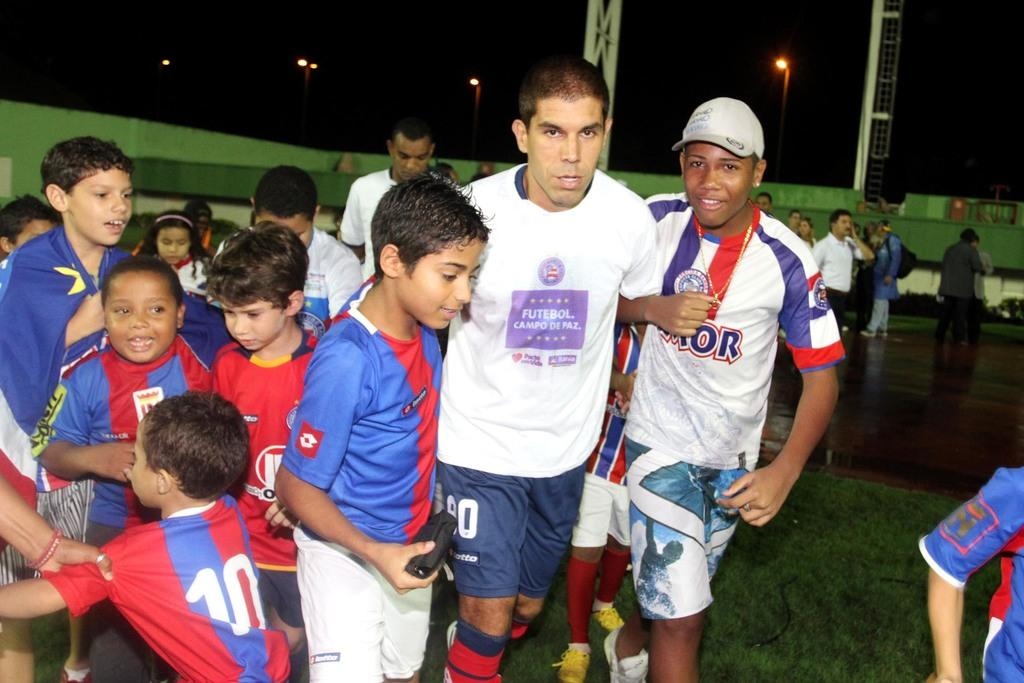What can be seen in the image? There are people standing in the image. Where are the people standing? The people are standing on the ground and floor. What can be seen in the background of the image? There are street poles, street lights, and grills in the background of the image. What is visible in the sky in the image? The sky is visible in the background of the image. What type of nut can be seen growing on the coast in the image? There is no nut or coast present in the image; it features people standing on the ground and floor with street poles, street lights, and grills in the background. 